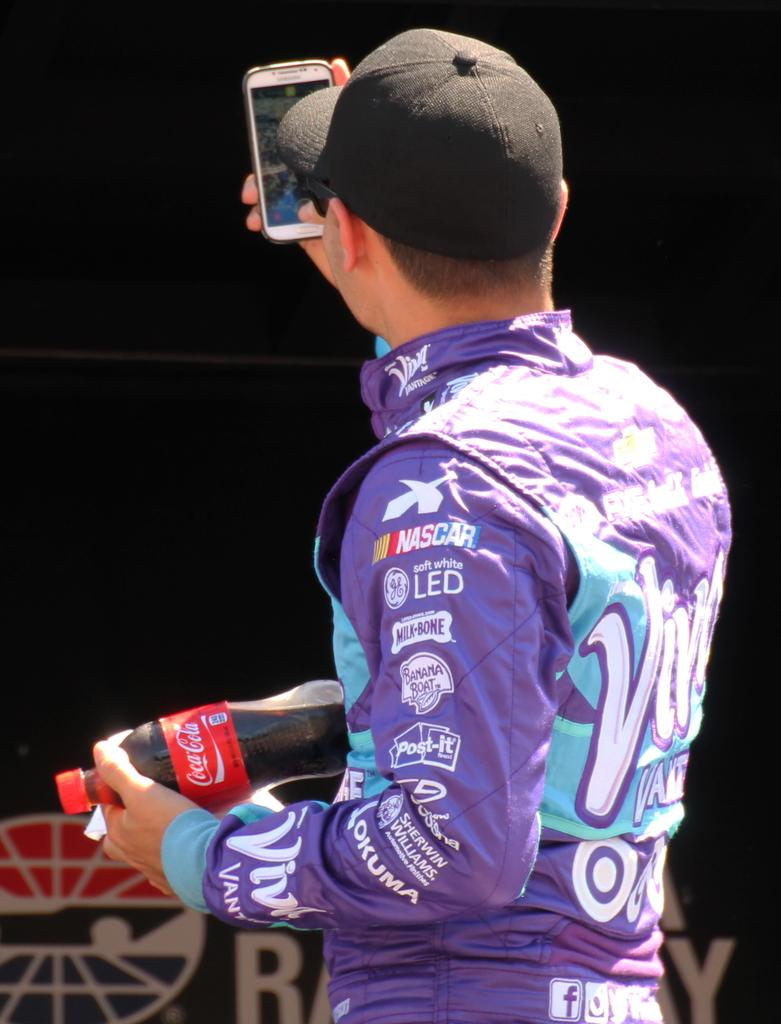<image>
Render a clear and concise summary of the photo. a racecar driver with sponsor like NASCAR on his jersey 